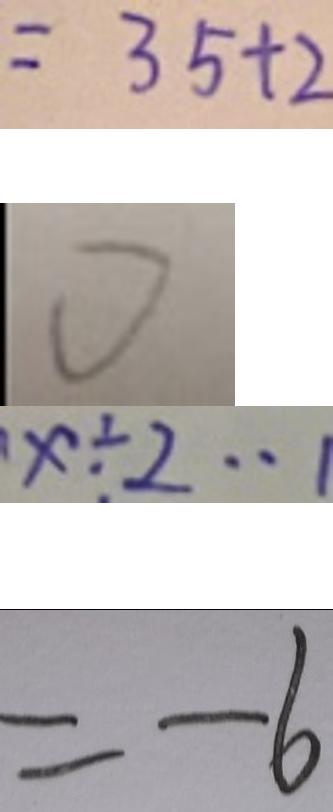Convert formula to latex. <formula><loc_0><loc_0><loc_500><loc_500>= 3 5 + 2 
 0 
 x \div 2 \cdots 1 
 = - 6</formula> 